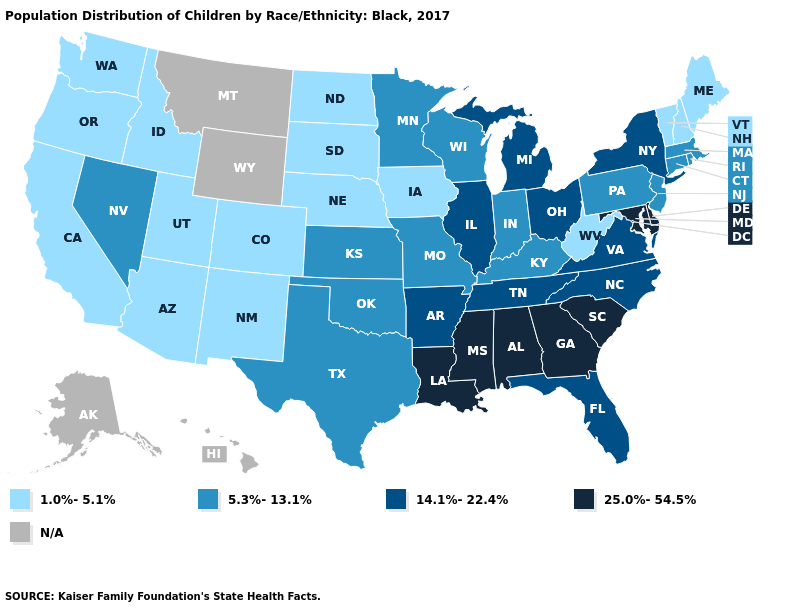What is the highest value in the West ?
Quick response, please. 5.3%-13.1%. Name the states that have a value in the range 25.0%-54.5%?
Short answer required. Alabama, Delaware, Georgia, Louisiana, Maryland, Mississippi, South Carolina. Which states have the highest value in the USA?
Quick response, please. Alabama, Delaware, Georgia, Louisiana, Maryland, Mississippi, South Carolina. How many symbols are there in the legend?
Give a very brief answer. 5. What is the value of Oklahoma?
Give a very brief answer. 5.3%-13.1%. Which states have the lowest value in the MidWest?
Write a very short answer. Iowa, Nebraska, North Dakota, South Dakota. What is the value of New York?
Concise answer only. 14.1%-22.4%. Does Kansas have the highest value in the USA?
Write a very short answer. No. Does the map have missing data?
Answer briefly. Yes. Name the states that have a value in the range 5.3%-13.1%?
Write a very short answer. Connecticut, Indiana, Kansas, Kentucky, Massachusetts, Minnesota, Missouri, Nevada, New Jersey, Oklahoma, Pennsylvania, Rhode Island, Texas, Wisconsin. Which states have the lowest value in the USA?
Answer briefly. Arizona, California, Colorado, Idaho, Iowa, Maine, Nebraska, New Hampshire, New Mexico, North Dakota, Oregon, South Dakota, Utah, Vermont, Washington, West Virginia. Name the states that have a value in the range 25.0%-54.5%?
Give a very brief answer. Alabama, Delaware, Georgia, Louisiana, Maryland, Mississippi, South Carolina. Name the states that have a value in the range 14.1%-22.4%?
Answer briefly. Arkansas, Florida, Illinois, Michigan, New York, North Carolina, Ohio, Tennessee, Virginia. What is the lowest value in states that border Alabama?
Be succinct. 14.1%-22.4%. 